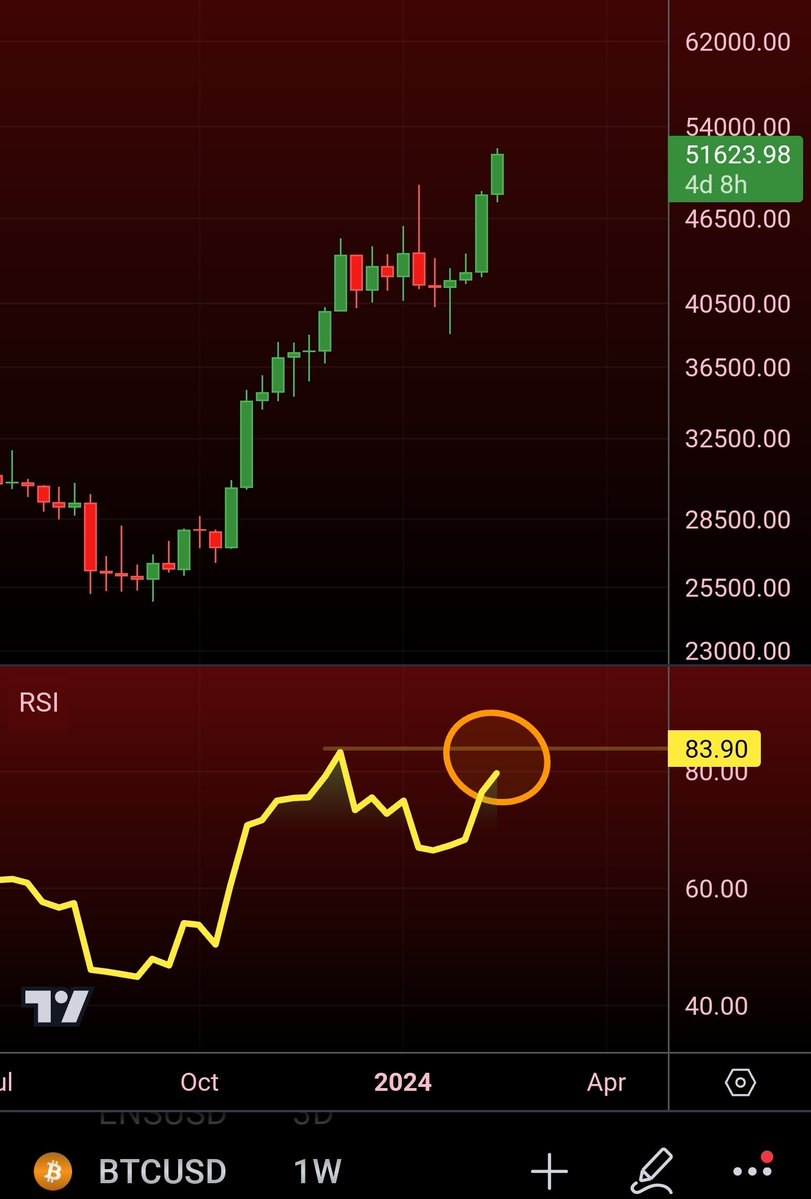SHOULD I BUY OR SELL The RSI indicator is showing a reading of 83.90, which is in the overbought zone. This suggests that the market is overvalued and that a correction may be due. Therefore, it may be advisable to sell. 